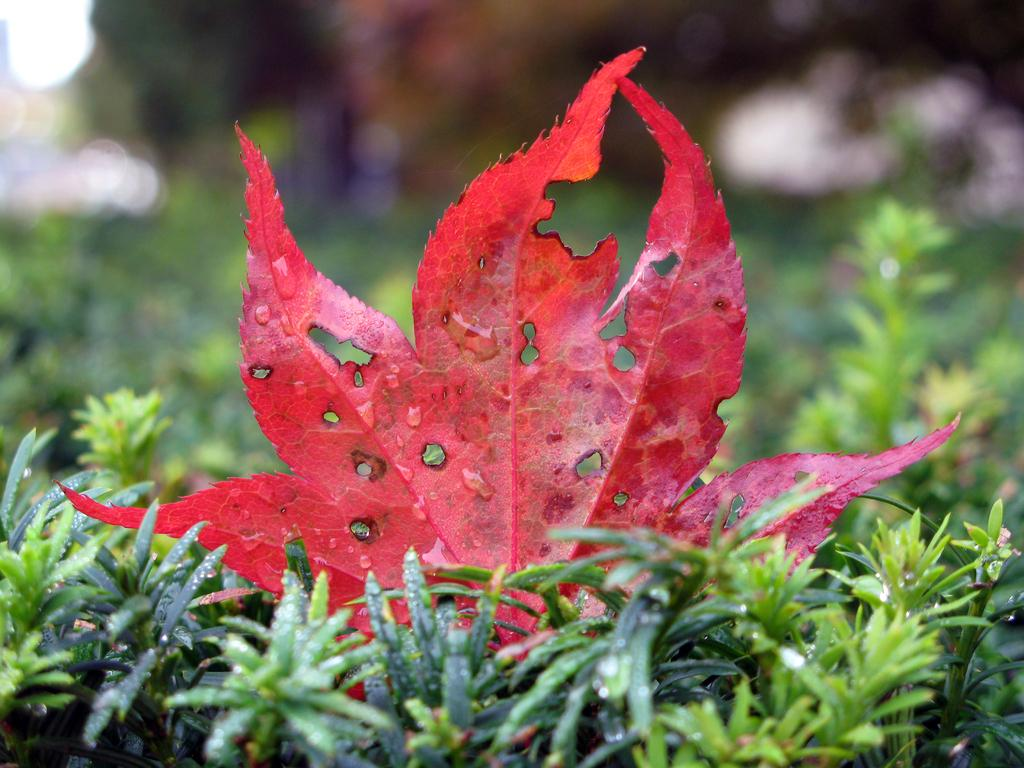What is: What is the most prominent color in the image? There is a red color leaf in the front of the image. What type of objects can be seen at the bottom of the image? There are plants at the bottom of the image. How would you describe the background of the image? The background of the image is blurry. What does the caption on the leaf say in the image? There is no caption on the leaf in the image. What is the desire of the plants at the bottom of the image? The image does not provide information about the desires of the plants. 